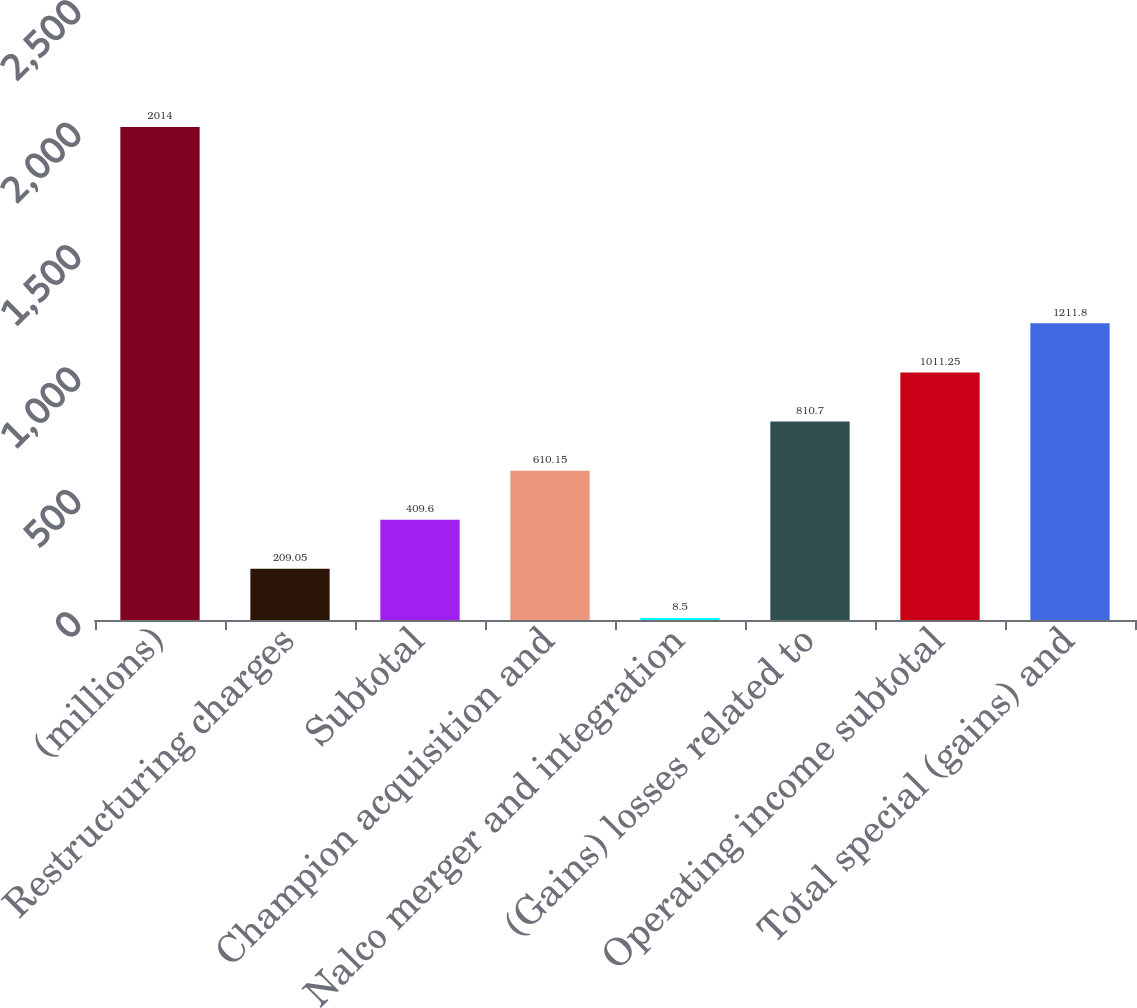Convert chart to OTSL. <chart><loc_0><loc_0><loc_500><loc_500><bar_chart><fcel>(millions)<fcel>Restructuring charges<fcel>Subtotal<fcel>Champion acquisition and<fcel>Nalco merger and integration<fcel>(Gains) losses related to<fcel>Operating income subtotal<fcel>Total special (gains) and<nl><fcel>2014<fcel>209.05<fcel>409.6<fcel>610.15<fcel>8.5<fcel>810.7<fcel>1011.25<fcel>1211.8<nl></chart> 